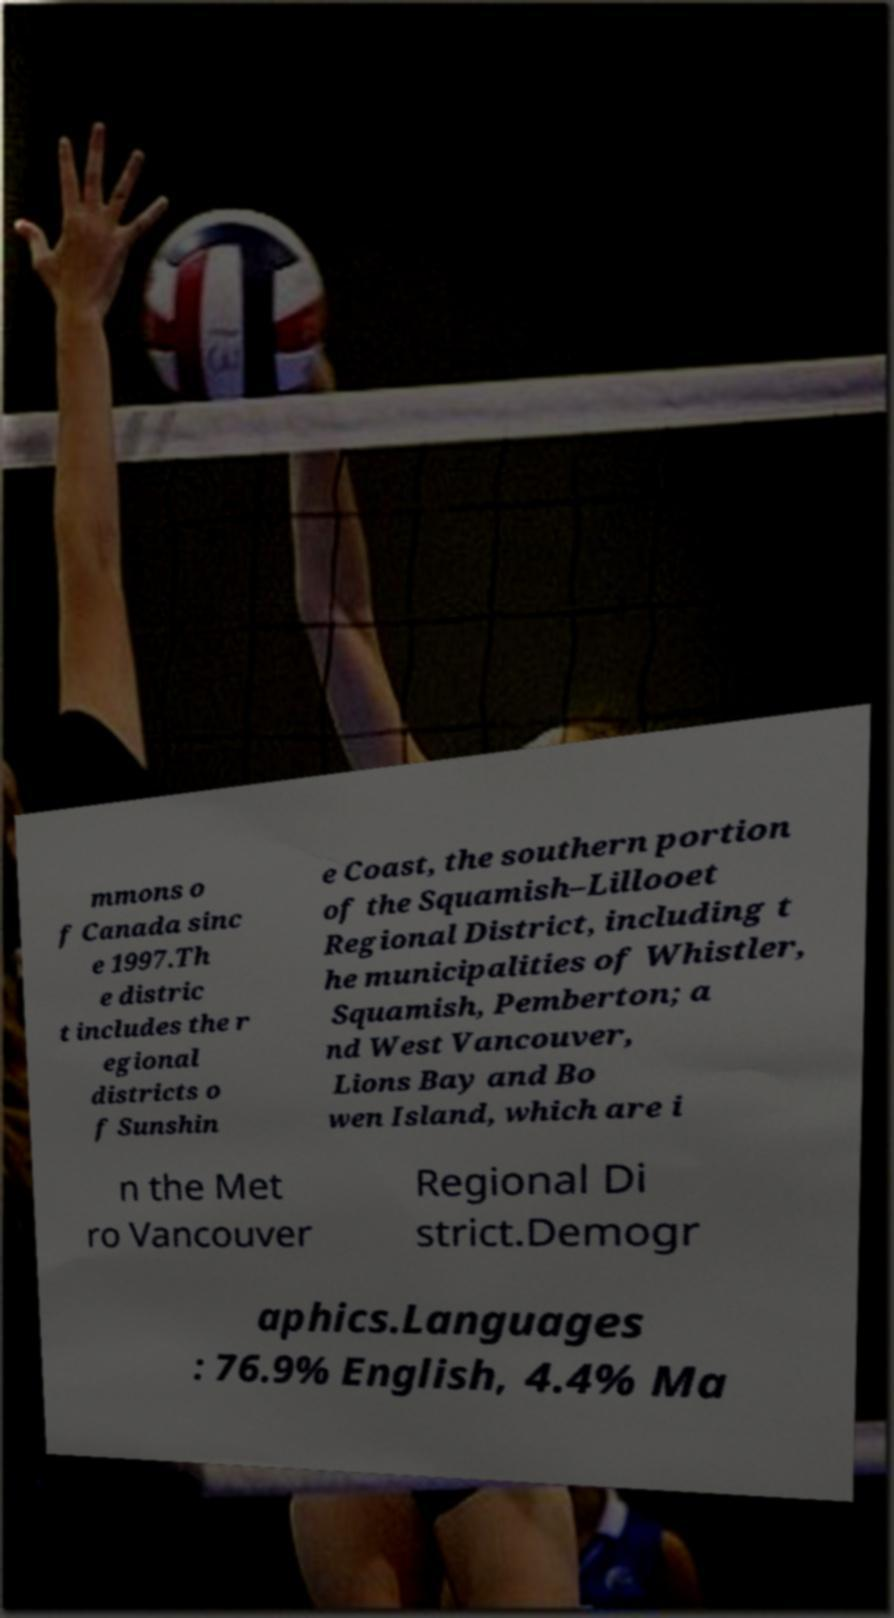What messages or text are displayed in this image? I need them in a readable, typed format. mmons o f Canada sinc e 1997.Th e distric t includes the r egional districts o f Sunshin e Coast, the southern portion of the Squamish–Lillooet Regional District, including t he municipalities of Whistler, Squamish, Pemberton; a nd West Vancouver, Lions Bay and Bo wen Island, which are i n the Met ro Vancouver Regional Di strict.Demogr aphics.Languages : 76.9% English, 4.4% Ma 